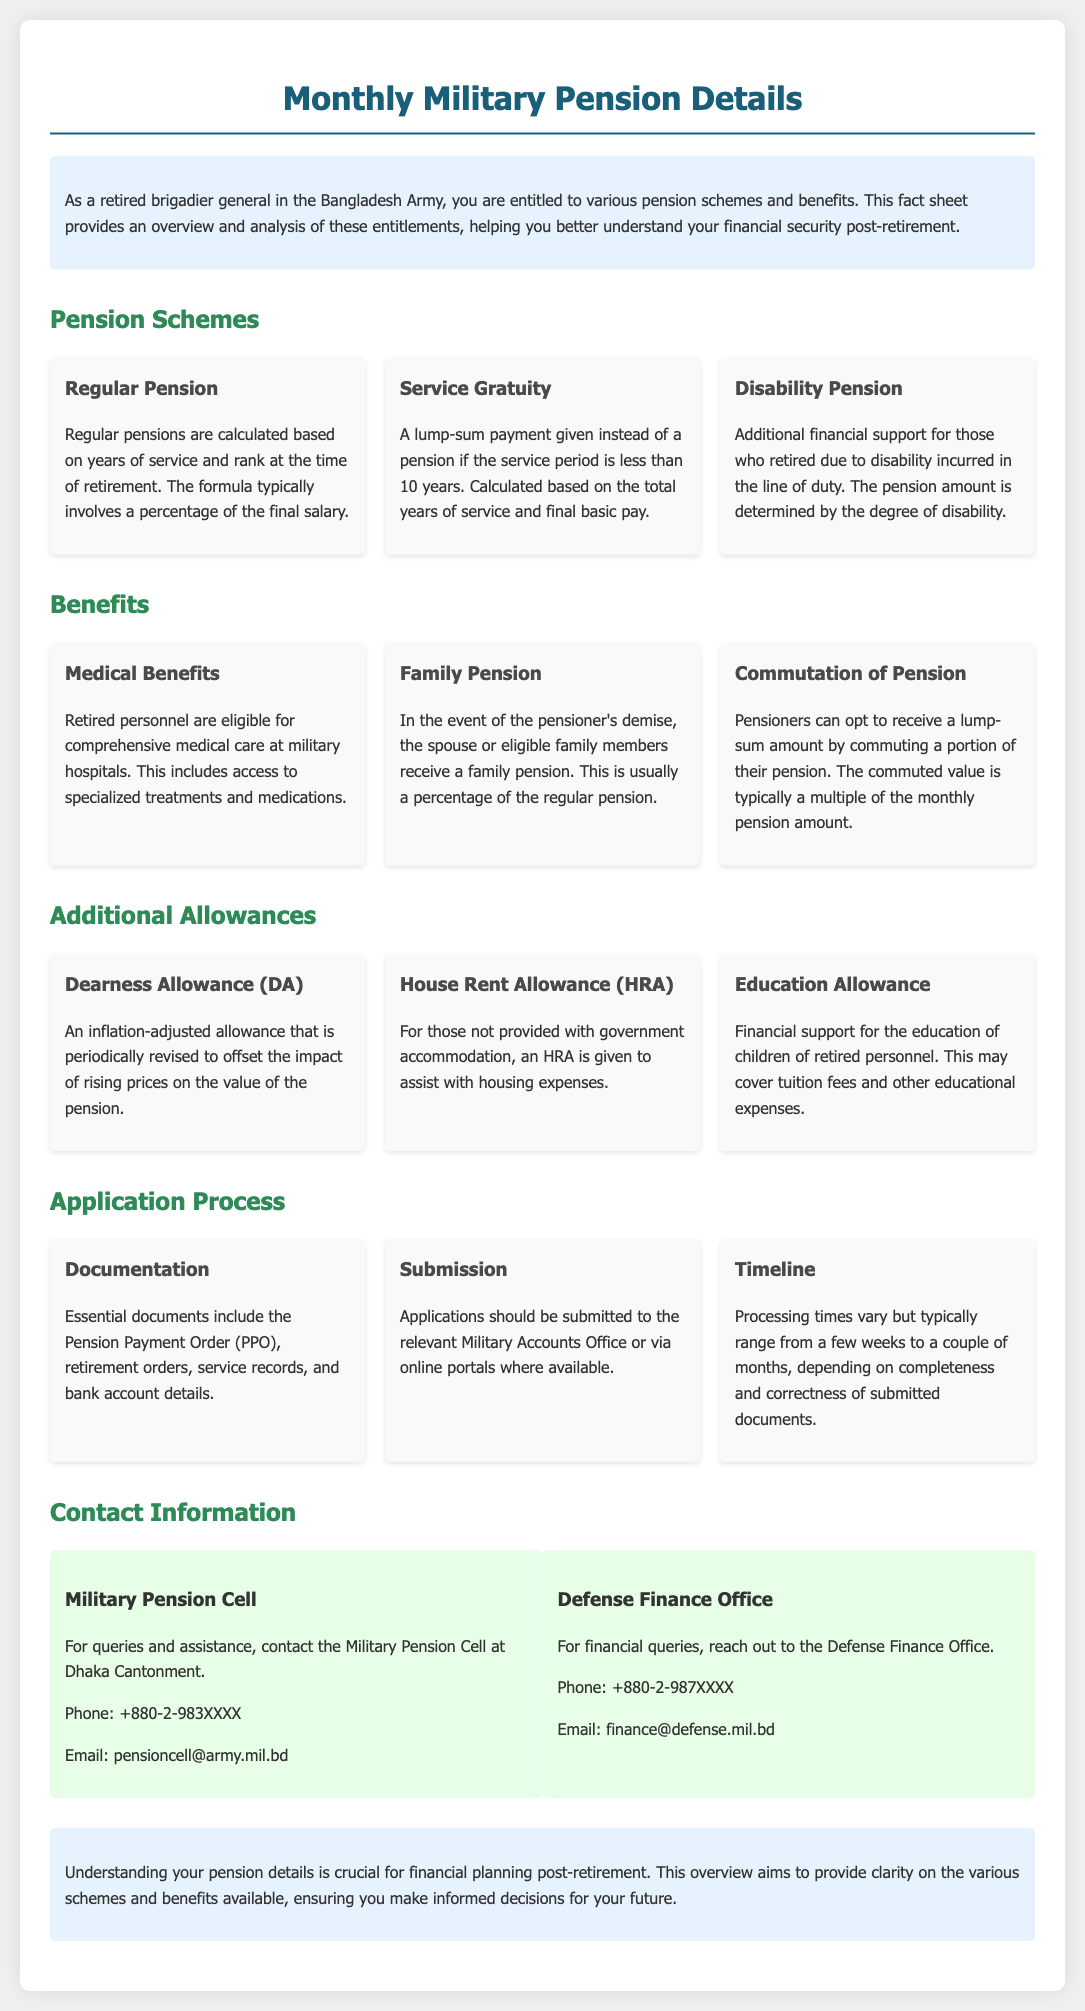what is the primary benefit of regular pensions? Regular pensions provide financial stability calculated based on years of service and rank.
Answer: financial stability what is the percentage of family pension? The family pension is usually a percentage of the regular pension.
Answer: percentage of regular pension how is the service gratuity calculated? Service gratuity is calculated based on total years of service and final basic pay.
Answer: total years of service and final basic pay who receives medical benefits? Retired personnel are eligible for comprehensive medical care at military hospitals.
Answer: Retired personnel what essential document is needed for pension application? The Pension Payment Order (PPO) is essential for the application process.
Answer: Pension Payment Order (PPO) what type of pension is available for retired personnel due to disability? Disability pension provides additional support for those who retired due to disability.
Answer: Disability pension what is the contact phone number for the Military Pension Cell? The contact phone number for the Military Pension Cell is +880-2-983XXXX.
Answer: +880-2-983XXXX how long does the processing time for the pension application usually take? Processing times usually range from a few weeks to a couple of months.
Answer: a few weeks to a couple of months what is one type of additional allowance provided to pensioners? Dearness Allowance (DA) helps offset the impact of rising prices.
Answer: Dearness Allowance (DA) 